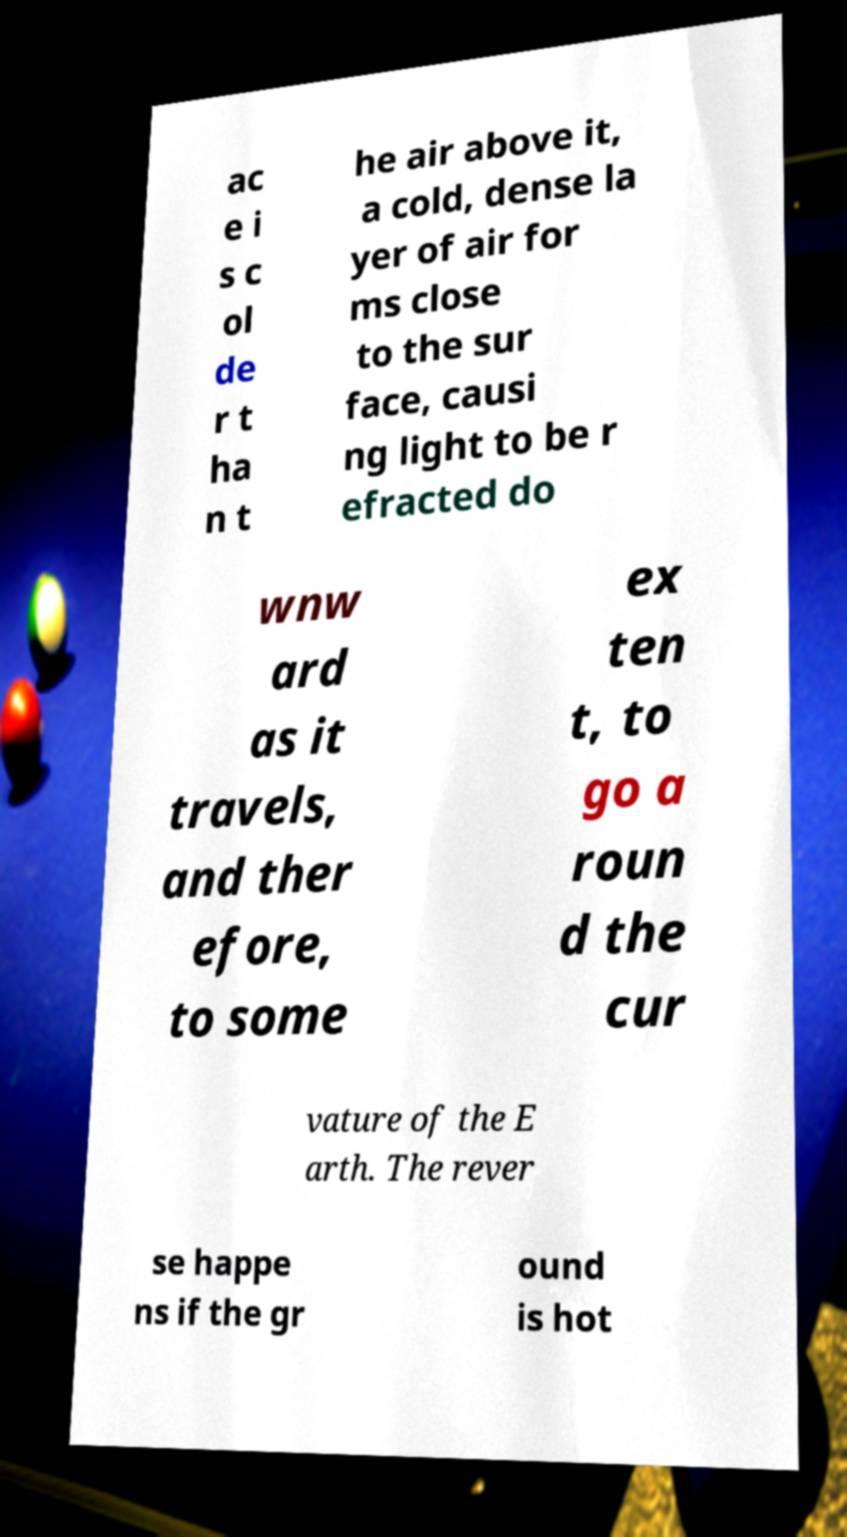Can you read and provide the text displayed in the image?This photo seems to have some interesting text. Can you extract and type it out for me? ac e i s c ol de r t ha n t he air above it, a cold, dense la yer of air for ms close to the sur face, causi ng light to be r efracted do wnw ard as it travels, and ther efore, to some ex ten t, to go a roun d the cur vature of the E arth. The rever se happe ns if the gr ound is hot 